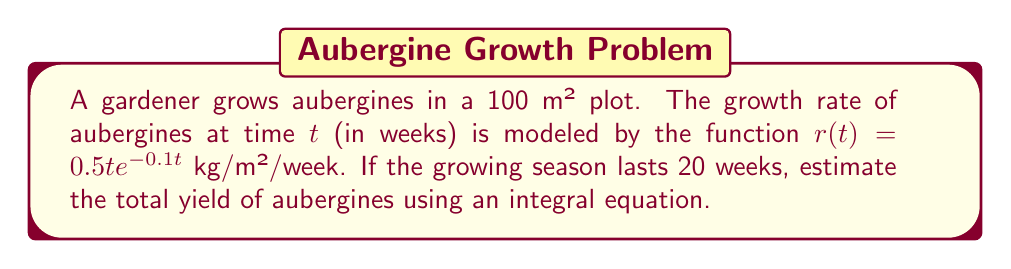Teach me how to tackle this problem. To estimate the total yield of aubergines, we need to integrate the growth rate function over the entire growing season and multiply it by the area of the plot. Let's approach this step-by-step:

1) The growth rate function is given as:
   $r(t) = 0.5t e^{-0.1t}$ kg/m²/week

2) To find the total yield per square meter, we need to integrate this function from t = 0 to t = 20:
   $Y = \int_0^{20} r(t) dt = \int_0^{20} 0.5t e^{-0.1t} dt$

3) This integral can be solved using integration by parts. Let:
   $u = t$, $du = dt$
   $dv = 0.5e^{-0.1t} dt$, $v = -5e^{-0.1t}$

4) Applying integration by parts:
   $Y = [-5te^{-0.1t}]_0^{20} + \int_0^{20} 5e^{-0.1t} dt$

5) Solving the definite integral:
   $Y = [-5te^{-0.1t}]_0^{20} + [-50e^{-0.1t}]_0^{20}$
   $Y = (-100e^{-2} + 0) + (-50e^{-2} + 50)$
   $Y \approx 13.53$ kg/m²

6) The total yield for the 100 m² plot is:
   Total Yield = $100 \times 13.53 = 1353$ kg

Therefore, the estimated total yield of aubergines for the season is approximately 1353 kg.
Answer: 1353 kg 